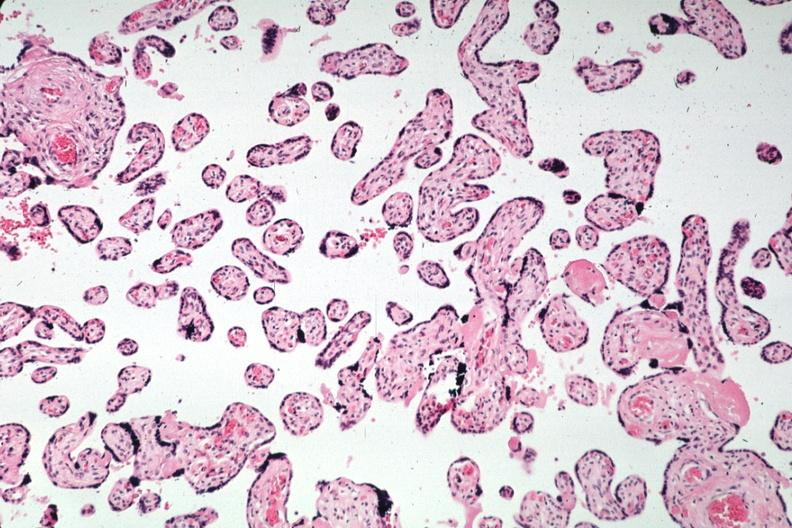what is present?
Answer the question using a single word or phrase. Female reproductive 